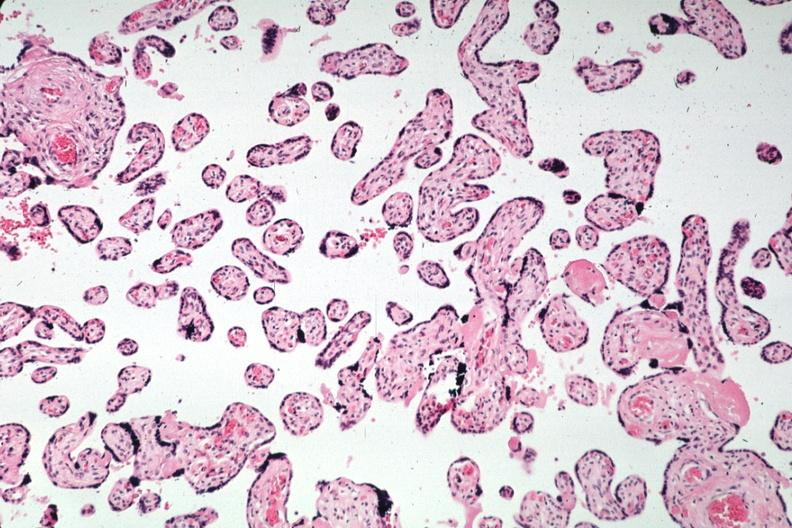what is present?
Answer the question using a single word or phrase. Female reproductive 